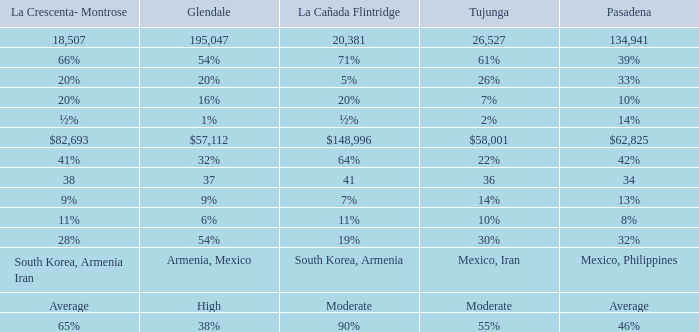What is the percentage of Glendale when Pasadena is 14%? 1%. Would you mind parsing the complete table? {'header': ['La Crescenta- Montrose', 'Glendale', 'La Cañada Flintridge', 'Tujunga', 'Pasadena'], 'rows': [['18,507', '195,047', '20,381', '26,527', '134,941'], ['66%', '54%', '71%', '61%', '39%'], ['20%', '20%', '5%', '26%', '33%'], ['20%', '16%', '20%', '7%', '10%'], ['½%', '1%', '½%', '2%', '14%'], ['$82,693', '$57,112', '$148,996', '$58,001', '$62,825'], ['41%', '32%', '64%', '22%', '42%'], ['38', '37', '41', '36', '34'], ['9%', '9%', '7%', '14%', '13%'], ['11%', '6%', '11%', '10%', '8%'], ['28%', '54%', '19%', '30%', '32%'], ['South Korea, Armenia Iran', 'Armenia, Mexico', 'South Korea, Armenia', 'Mexico, Iran', 'Mexico, Philippines'], ['Average', 'High', 'Moderate', 'Moderate', 'Average'], ['65%', '38%', '90%', '55%', '46%']]} 